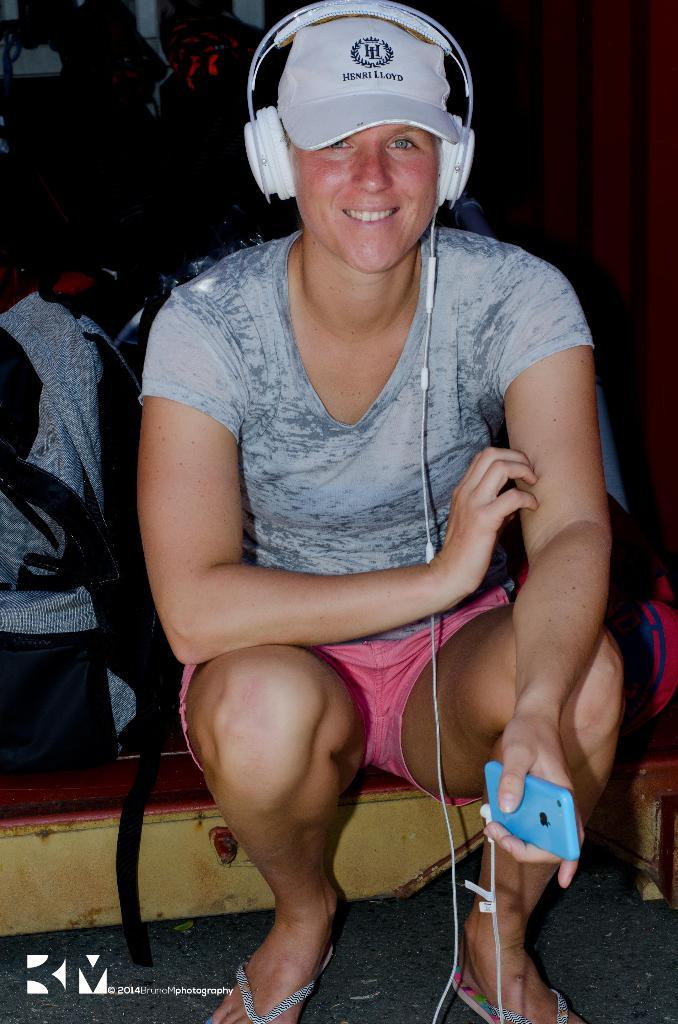Who is the main subject in the image? There is a woman in the image. What is the woman doing in the image? The woman is sitting on the floor. What is the woman holding in her hand? The woman is holding a mobile. What is the woman wearing on her ears? The woman has headsets. What is the woman wearing on her head? The woman is wearing a cap. What is the woman's facial expression in the image? The woman is smiling. What shape is the moon in the image? There is no moon present in the image. What sound can be heard coming from the thunder in the image? There is no thunder present in the image. 